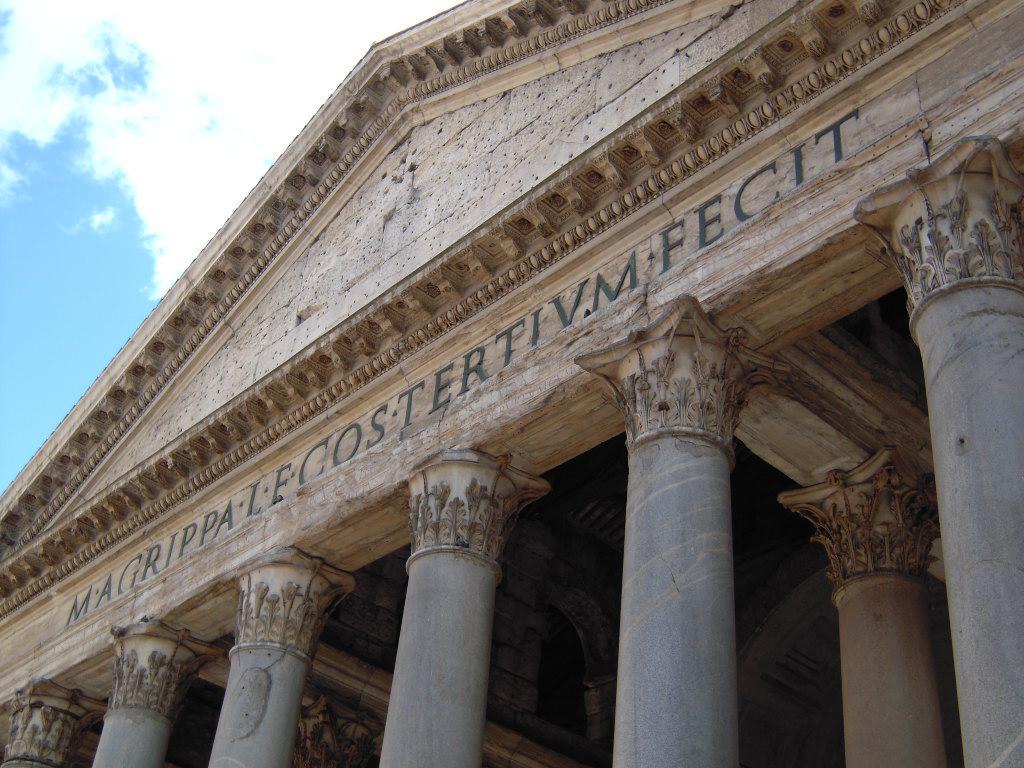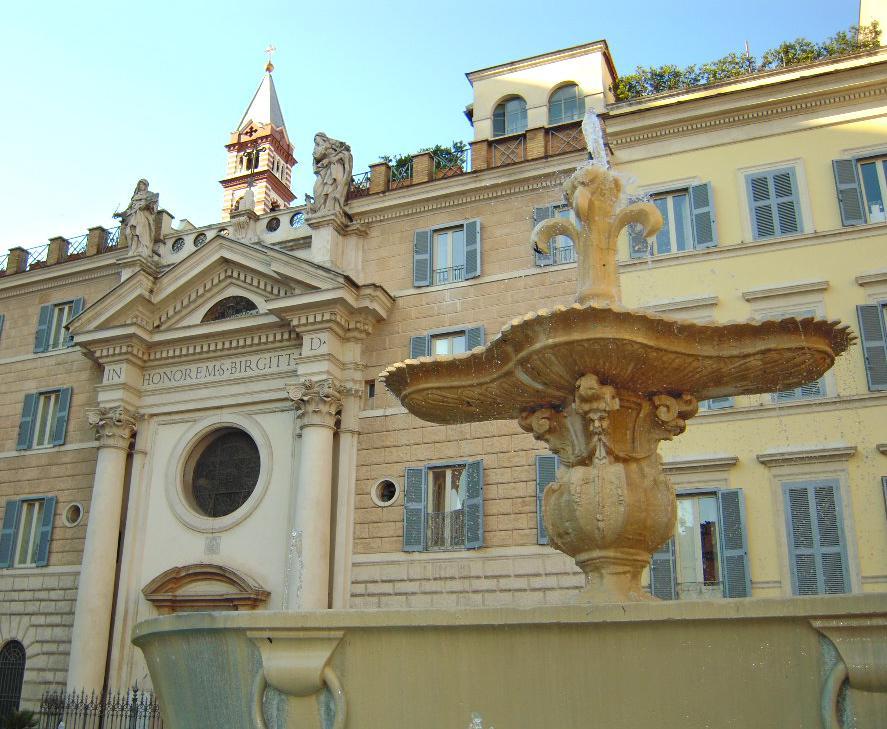The first image is the image on the left, the second image is the image on the right. Considering the images on both sides, is "In at least one image there is a building built out of white brick carved in to the side of a mountain." valid? Answer yes or no. No. The first image is the image on the left, the second image is the image on the right. Analyze the images presented: Is the assertion "An image shows a beige building with a row of arch shapes on the bottom, many rectangular windows below a flat roof, and a mountainside in the background." valid? Answer yes or no. No. 